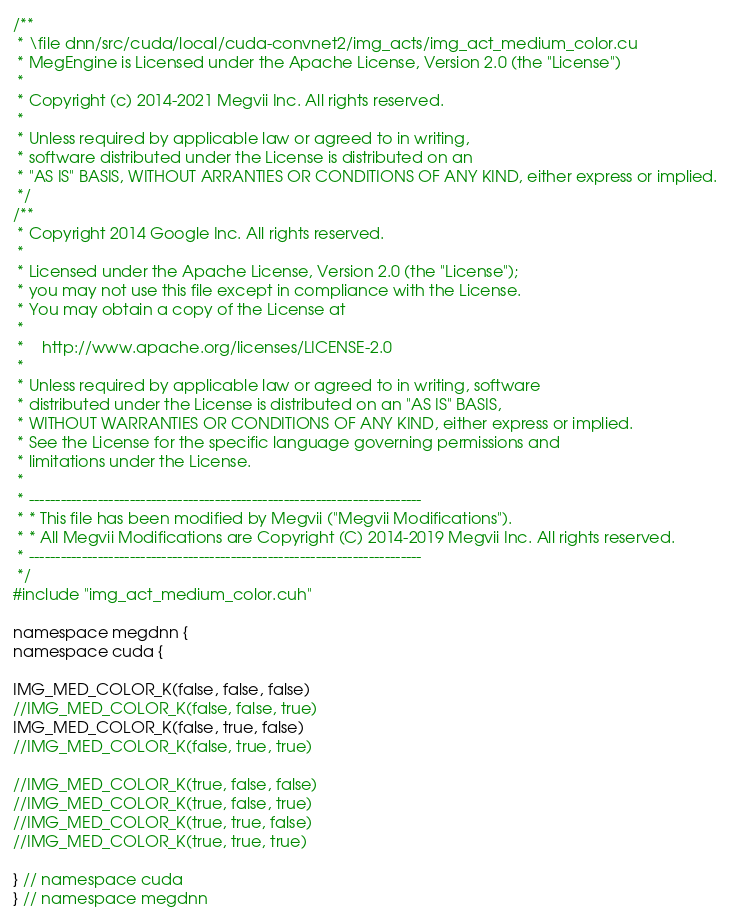Convert code to text. <code><loc_0><loc_0><loc_500><loc_500><_Cuda_>/**
 * \file dnn/src/cuda/local/cuda-convnet2/img_acts/img_act_medium_color.cu
 * MegEngine is Licensed under the Apache License, Version 2.0 (the "License")
 *
 * Copyright (c) 2014-2021 Megvii Inc. All rights reserved.
 *
 * Unless required by applicable law or agreed to in writing,
 * software distributed under the License is distributed on an
 * "AS IS" BASIS, WITHOUT ARRANTIES OR CONDITIONS OF ANY KIND, either express or implied.
 */
/**
 * Copyright 2014 Google Inc. All rights reserved.
 *
 * Licensed under the Apache License, Version 2.0 (the "License");
 * you may not use this file except in compliance with the License.
 * You may obtain a copy of the License at
 *
 *    http://www.apache.org/licenses/LICENSE-2.0
 *
 * Unless required by applicable law or agreed to in writing, software
 * distributed under the License is distributed on an "AS IS" BASIS,
 * WITHOUT WARRANTIES OR CONDITIONS OF ANY KIND, either express or implied.
 * See the License for the specific language governing permissions and
 * limitations under the License.
 *
 * --------------------------------------------------------------------------
 * * This file has been modified by Megvii ("Megvii Modifications").
 * * All Megvii Modifications are Copyright (C) 2014-2019 Megvii Inc. All rights reserved.
 * --------------------------------------------------------------------------
 */
#include "img_act_medium_color.cuh"

namespace megdnn {
namespace cuda {

IMG_MED_COLOR_K(false, false, false)
//IMG_MED_COLOR_K(false, false, true)
IMG_MED_COLOR_K(false, true, false)
//IMG_MED_COLOR_K(false, true, true)

//IMG_MED_COLOR_K(true, false, false)
//IMG_MED_COLOR_K(true, false, true)
//IMG_MED_COLOR_K(true, true, false)
//IMG_MED_COLOR_K(true, true, true)

} // namespace cuda
} // namespace megdnn
</code> 